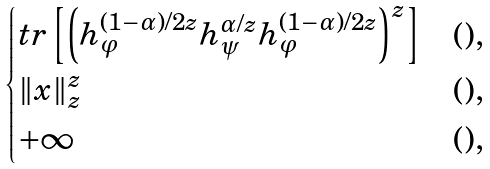<formula> <loc_0><loc_0><loc_500><loc_500>\begin{cases} t r \left [ \left ( h _ { \varphi } ^ { ( 1 - \alpha ) / 2 z } h _ { \psi } ^ { \alpha / z } h _ { \varphi } ^ { ( 1 - \alpha ) / 2 z } \right ) ^ { z } \right ] & ( ) , \\ \| x \| _ { z } ^ { z } & ( ) , \\ + \infty & ( ) , \end{cases}</formula> 